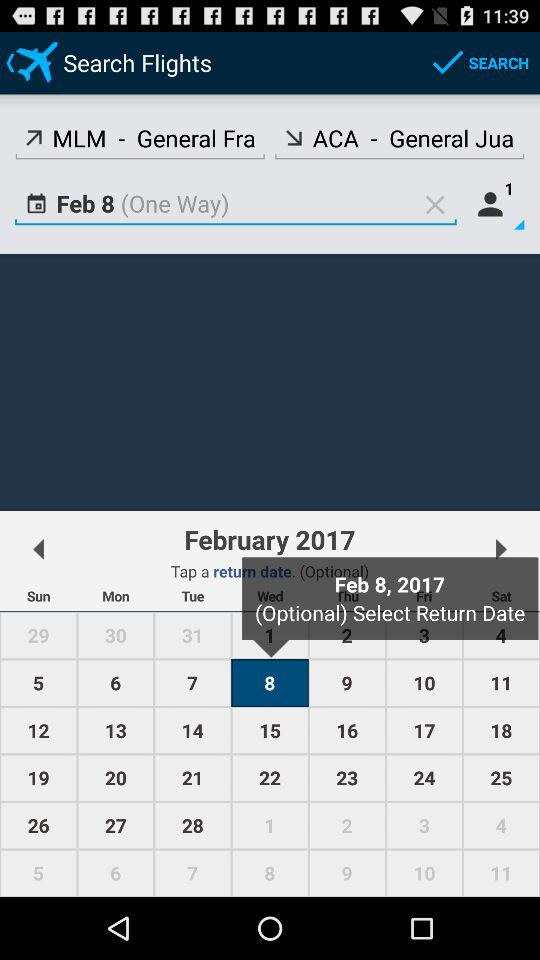What is the location where the flight will land? The location where the flight will land is "ACA-General Jua". 